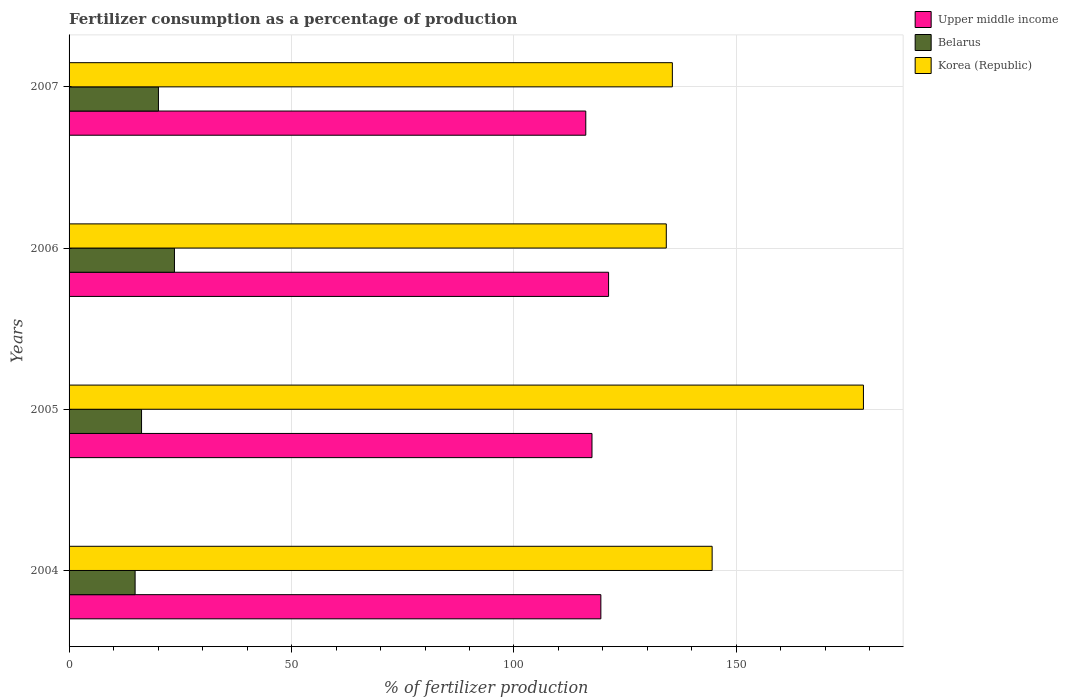What is the label of the 1st group of bars from the top?
Your response must be concise. 2007. What is the percentage of fertilizers consumed in Upper middle income in 2007?
Your answer should be very brief. 116.14. Across all years, what is the maximum percentage of fertilizers consumed in Korea (Republic)?
Make the answer very short. 178.54. Across all years, what is the minimum percentage of fertilizers consumed in Belarus?
Give a very brief answer. 14.84. In which year was the percentage of fertilizers consumed in Belarus maximum?
Provide a succinct answer. 2006. What is the total percentage of fertilizers consumed in Korea (Republic) in the graph?
Provide a short and direct response. 592.91. What is the difference between the percentage of fertilizers consumed in Belarus in 2005 and that in 2007?
Your response must be concise. -3.79. What is the difference between the percentage of fertilizers consumed in Belarus in 2005 and the percentage of fertilizers consumed in Korea (Republic) in 2007?
Your answer should be compact. -119.31. What is the average percentage of fertilizers consumed in Belarus per year?
Your response must be concise. 18.73. In the year 2004, what is the difference between the percentage of fertilizers consumed in Korea (Republic) and percentage of fertilizers consumed in Belarus?
Give a very brief answer. 129.69. In how many years, is the percentage of fertilizers consumed in Upper middle income greater than 50 %?
Offer a very short reply. 4. What is the ratio of the percentage of fertilizers consumed in Upper middle income in 2005 to that in 2006?
Your response must be concise. 0.97. What is the difference between the highest and the second highest percentage of fertilizers consumed in Korea (Republic)?
Make the answer very short. 34.01. What is the difference between the highest and the lowest percentage of fertilizers consumed in Upper middle income?
Your response must be concise. 5.12. Is the sum of the percentage of fertilizers consumed in Belarus in 2006 and 2007 greater than the maximum percentage of fertilizers consumed in Korea (Republic) across all years?
Ensure brevity in your answer.  No. What does the 2nd bar from the top in 2005 represents?
Your answer should be very brief. Belarus. What does the 3rd bar from the bottom in 2007 represents?
Offer a terse response. Korea (Republic). Is it the case that in every year, the sum of the percentage of fertilizers consumed in Upper middle income and percentage of fertilizers consumed in Belarus is greater than the percentage of fertilizers consumed in Korea (Republic)?
Your answer should be compact. No. What is the difference between two consecutive major ticks on the X-axis?
Your answer should be compact. 50. Does the graph contain any zero values?
Offer a terse response. No. How many legend labels are there?
Make the answer very short. 3. How are the legend labels stacked?
Give a very brief answer. Vertical. What is the title of the graph?
Offer a very short reply. Fertilizer consumption as a percentage of production. Does "Tanzania" appear as one of the legend labels in the graph?
Offer a very short reply. No. What is the label or title of the X-axis?
Provide a short and direct response. % of fertilizer production. What is the % of fertilizer production of Upper middle income in 2004?
Your answer should be very brief. 119.53. What is the % of fertilizer production of Belarus in 2004?
Provide a succinct answer. 14.84. What is the % of fertilizer production in Korea (Republic) in 2004?
Ensure brevity in your answer.  144.54. What is the % of fertilizer production in Upper middle income in 2005?
Offer a terse response. 117.53. What is the % of fertilizer production in Belarus in 2005?
Keep it short and to the point. 16.29. What is the % of fertilizer production in Korea (Republic) in 2005?
Your response must be concise. 178.54. What is the % of fertilizer production of Upper middle income in 2006?
Offer a very short reply. 121.26. What is the % of fertilizer production of Belarus in 2006?
Provide a short and direct response. 23.69. What is the % of fertilizer production in Korea (Republic) in 2006?
Your answer should be very brief. 134.23. What is the % of fertilizer production of Upper middle income in 2007?
Ensure brevity in your answer.  116.14. What is the % of fertilizer production in Belarus in 2007?
Your answer should be compact. 20.09. What is the % of fertilizer production of Korea (Republic) in 2007?
Provide a succinct answer. 135.6. Across all years, what is the maximum % of fertilizer production in Upper middle income?
Offer a terse response. 121.26. Across all years, what is the maximum % of fertilizer production of Belarus?
Ensure brevity in your answer.  23.69. Across all years, what is the maximum % of fertilizer production of Korea (Republic)?
Make the answer very short. 178.54. Across all years, what is the minimum % of fertilizer production of Upper middle income?
Provide a short and direct response. 116.14. Across all years, what is the minimum % of fertilizer production in Belarus?
Give a very brief answer. 14.84. Across all years, what is the minimum % of fertilizer production of Korea (Republic)?
Keep it short and to the point. 134.23. What is the total % of fertilizer production of Upper middle income in the graph?
Offer a very short reply. 474.46. What is the total % of fertilizer production in Belarus in the graph?
Provide a succinct answer. 74.91. What is the total % of fertilizer production in Korea (Republic) in the graph?
Your response must be concise. 592.91. What is the difference between the % of fertilizer production in Upper middle income in 2004 and that in 2005?
Your response must be concise. 2. What is the difference between the % of fertilizer production in Belarus in 2004 and that in 2005?
Offer a terse response. -1.45. What is the difference between the % of fertilizer production in Korea (Republic) in 2004 and that in 2005?
Keep it short and to the point. -34.01. What is the difference between the % of fertilizer production in Upper middle income in 2004 and that in 2006?
Offer a very short reply. -1.73. What is the difference between the % of fertilizer production in Belarus in 2004 and that in 2006?
Offer a very short reply. -8.84. What is the difference between the % of fertilizer production in Korea (Republic) in 2004 and that in 2006?
Give a very brief answer. 10.3. What is the difference between the % of fertilizer production of Upper middle income in 2004 and that in 2007?
Offer a very short reply. 3.39. What is the difference between the % of fertilizer production of Belarus in 2004 and that in 2007?
Your response must be concise. -5.24. What is the difference between the % of fertilizer production in Korea (Republic) in 2004 and that in 2007?
Your answer should be very brief. 8.94. What is the difference between the % of fertilizer production in Upper middle income in 2005 and that in 2006?
Provide a short and direct response. -3.73. What is the difference between the % of fertilizer production of Belarus in 2005 and that in 2006?
Provide a short and direct response. -7.39. What is the difference between the % of fertilizer production of Korea (Republic) in 2005 and that in 2006?
Your answer should be compact. 44.31. What is the difference between the % of fertilizer production of Upper middle income in 2005 and that in 2007?
Make the answer very short. 1.4. What is the difference between the % of fertilizer production in Belarus in 2005 and that in 2007?
Provide a succinct answer. -3.79. What is the difference between the % of fertilizer production in Korea (Republic) in 2005 and that in 2007?
Provide a succinct answer. 42.95. What is the difference between the % of fertilizer production of Upper middle income in 2006 and that in 2007?
Give a very brief answer. 5.12. What is the difference between the % of fertilizer production in Belarus in 2006 and that in 2007?
Your answer should be very brief. 3.6. What is the difference between the % of fertilizer production in Korea (Republic) in 2006 and that in 2007?
Your answer should be compact. -1.36. What is the difference between the % of fertilizer production in Upper middle income in 2004 and the % of fertilizer production in Belarus in 2005?
Keep it short and to the point. 103.24. What is the difference between the % of fertilizer production in Upper middle income in 2004 and the % of fertilizer production in Korea (Republic) in 2005?
Provide a short and direct response. -59.02. What is the difference between the % of fertilizer production in Belarus in 2004 and the % of fertilizer production in Korea (Republic) in 2005?
Ensure brevity in your answer.  -163.7. What is the difference between the % of fertilizer production of Upper middle income in 2004 and the % of fertilizer production of Belarus in 2006?
Give a very brief answer. 95.84. What is the difference between the % of fertilizer production of Upper middle income in 2004 and the % of fertilizer production of Korea (Republic) in 2006?
Offer a very short reply. -14.7. What is the difference between the % of fertilizer production of Belarus in 2004 and the % of fertilizer production of Korea (Republic) in 2006?
Offer a very short reply. -119.39. What is the difference between the % of fertilizer production of Upper middle income in 2004 and the % of fertilizer production of Belarus in 2007?
Offer a very short reply. 99.44. What is the difference between the % of fertilizer production of Upper middle income in 2004 and the % of fertilizer production of Korea (Republic) in 2007?
Your response must be concise. -16.07. What is the difference between the % of fertilizer production of Belarus in 2004 and the % of fertilizer production of Korea (Republic) in 2007?
Your answer should be very brief. -120.75. What is the difference between the % of fertilizer production of Upper middle income in 2005 and the % of fertilizer production of Belarus in 2006?
Keep it short and to the point. 93.85. What is the difference between the % of fertilizer production of Upper middle income in 2005 and the % of fertilizer production of Korea (Republic) in 2006?
Your answer should be very brief. -16.7. What is the difference between the % of fertilizer production of Belarus in 2005 and the % of fertilizer production of Korea (Republic) in 2006?
Make the answer very short. -117.94. What is the difference between the % of fertilizer production of Upper middle income in 2005 and the % of fertilizer production of Belarus in 2007?
Your response must be concise. 97.45. What is the difference between the % of fertilizer production of Upper middle income in 2005 and the % of fertilizer production of Korea (Republic) in 2007?
Provide a succinct answer. -18.06. What is the difference between the % of fertilizer production in Belarus in 2005 and the % of fertilizer production in Korea (Republic) in 2007?
Offer a very short reply. -119.31. What is the difference between the % of fertilizer production in Upper middle income in 2006 and the % of fertilizer production in Belarus in 2007?
Give a very brief answer. 101.18. What is the difference between the % of fertilizer production in Upper middle income in 2006 and the % of fertilizer production in Korea (Republic) in 2007?
Offer a very short reply. -14.34. What is the difference between the % of fertilizer production of Belarus in 2006 and the % of fertilizer production of Korea (Republic) in 2007?
Ensure brevity in your answer.  -111.91. What is the average % of fertilizer production of Upper middle income per year?
Provide a short and direct response. 118.62. What is the average % of fertilizer production of Belarus per year?
Your answer should be compact. 18.73. What is the average % of fertilizer production in Korea (Republic) per year?
Your response must be concise. 148.23. In the year 2004, what is the difference between the % of fertilizer production of Upper middle income and % of fertilizer production of Belarus?
Your answer should be compact. 104.69. In the year 2004, what is the difference between the % of fertilizer production in Upper middle income and % of fertilizer production in Korea (Republic)?
Your response must be concise. -25.01. In the year 2004, what is the difference between the % of fertilizer production in Belarus and % of fertilizer production in Korea (Republic)?
Your answer should be very brief. -129.69. In the year 2005, what is the difference between the % of fertilizer production of Upper middle income and % of fertilizer production of Belarus?
Provide a succinct answer. 101.24. In the year 2005, what is the difference between the % of fertilizer production in Upper middle income and % of fertilizer production in Korea (Republic)?
Make the answer very short. -61.01. In the year 2005, what is the difference between the % of fertilizer production in Belarus and % of fertilizer production in Korea (Republic)?
Ensure brevity in your answer.  -162.25. In the year 2006, what is the difference between the % of fertilizer production in Upper middle income and % of fertilizer production in Belarus?
Your answer should be very brief. 97.58. In the year 2006, what is the difference between the % of fertilizer production in Upper middle income and % of fertilizer production in Korea (Republic)?
Make the answer very short. -12.97. In the year 2006, what is the difference between the % of fertilizer production of Belarus and % of fertilizer production of Korea (Republic)?
Make the answer very short. -110.55. In the year 2007, what is the difference between the % of fertilizer production in Upper middle income and % of fertilizer production in Belarus?
Provide a succinct answer. 96.05. In the year 2007, what is the difference between the % of fertilizer production of Upper middle income and % of fertilizer production of Korea (Republic)?
Ensure brevity in your answer.  -19.46. In the year 2007, what is the difference between the % of fertilizer production in Belarus and % of fertilizer production in Korea (Republic)?
Offer a very short reply. -115.51. What is the ratio of the % of fertilizer production in Upper middle income in 2004 to that in 2005?
Provide a succinct answer. 1.02. What is the ratio of the % of fertilizer production in Belarus in 2004 to that in 2005?
Your answer should be compact. 0.91. What is the ratio of the % of fertilizer production of Korea (Republic) in 2004 to that in 2005?
Keep it short and to the point. 0.81. What is the ratio of the % of fertilizer production of Upper middle income in 2004 to that in 2006?
Provide a short and direct response. 0.99. What is the ratio of the % of fertilizer production of Belarus in 2004 to that in 2006?
Provide a succinct answer. 0.63. What is the ratio of the % of fertilizer production in Korea (Republic) in 2004 to that in 2006?
Give a very brief answer. 1.08. What is the ratio of the % of fertilizer production in Upper middle income in 2004 to that in 2007?
Offer a very short reply. 1.03. What is the ratio of the % of fertilizer production in Belarus in 2004 to that in 2007?
Make the answer very short. 0.74. What is the ratio of the % of fertilizer production in Korea (Republic) in 2004 to that in 2007?
Your answer should be very brief. 1.07. What is the ratio of the % of fertilizer production of Upper middle income in 2005 to that in 2006?
Your answer should be compact. 0.97. What is the ratio of the % of fertilizer production of Belarus in 2005 to that in 2006?
Give a very brief answer. 0.69. What is the ratio of the % of fertilizer production of Korea (Republic) in 2005 to that in 2006?
Offer a very short reply. 1.33. What is the ratio of the % of fertilizer production in Belarus in 2005 to that in 2007?
Your answer should be compact. 0.81. What is the ratio of the % of fertilizer production of Korea (Republic) in 2005 to that in 2007?
Your response must be concise. 1.32. What is the ratio of the % of fertilizer production of Upper middle income in 2006 to that in 2007?
Provide a short and direct response. 1.04. What is the ratio of the % of fertilizer production of Belarus in 2006 to that in 2007?
Provide a succinct answer. 1.18. What is the difference between the highest and the second highest % of fertilizer production in Upper middle income?
Provide a succinct answer. 1.73. What is the difference between the highest and the second highest % of fertilizer production in Belarus?
Provide a succinct answer. 3.6. What is the difference between the highest and the second highest % of fertilizer production in Korea (Republic)?
Ensure brevity in your answer.  34.01. What is the difference between the highest and the lowest % of fertilizer production in Upper middle income?
Offer a terse response. 5.12. What is the difference between the highest and the lowest % of fertilizer production in Belarus?
Give a very brief answer. 8.84. What is the difference between the highest and the lowest % of fertilizer production in Korea (Republic)?
Provide a short and direct response. 44.31. 